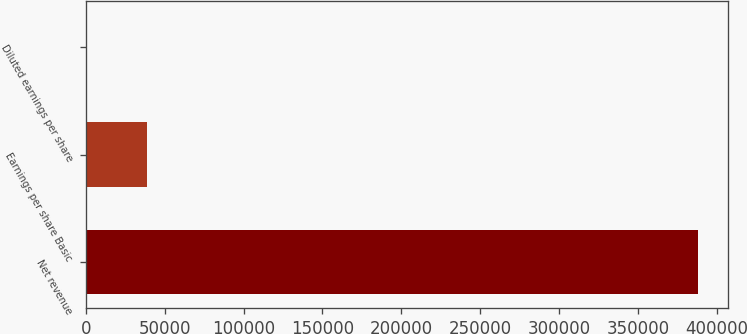Convert chart. <chart><loc_0><loc_0><loc_500><loc_500><bar_chart><fcel>Net revenue<fcel>Earnings per share Basic<fcel>Diluted earnings per share<nl><fcel>387982<fcel>38798.8<fcel>0.62<nl></chart> 